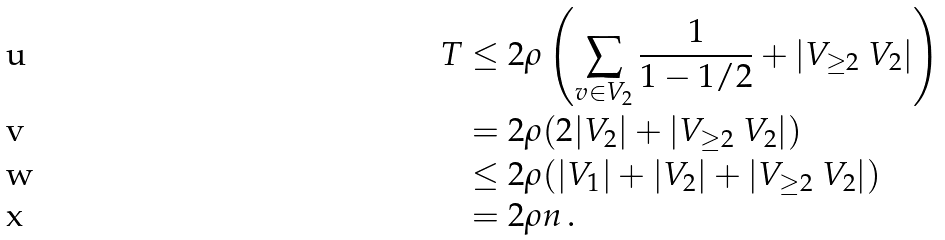Convert formula to latex. <formula><loc_0><loc_0><loc_500><loc_500>T & \leq 2 \rho \left ( \sum _ { v \in V _ { 2 } } \frac { 1 } { 1 - 1 / 2 } + | V _ { \geq 2 } \ V _ { 2 } | \right ) \\ & = 2 \rho ( 2 | V _ { 2 } | + | V _ { \geq 2 } \ V _ { 2 } | ) \\ & \leq 2 \rho ( | V _ { 1 } | + | V _ { 2 } | + | V _ { \geq 2 } \ V _ { 2 } | ) \\ & = 2 \rho n \, .</formula> 